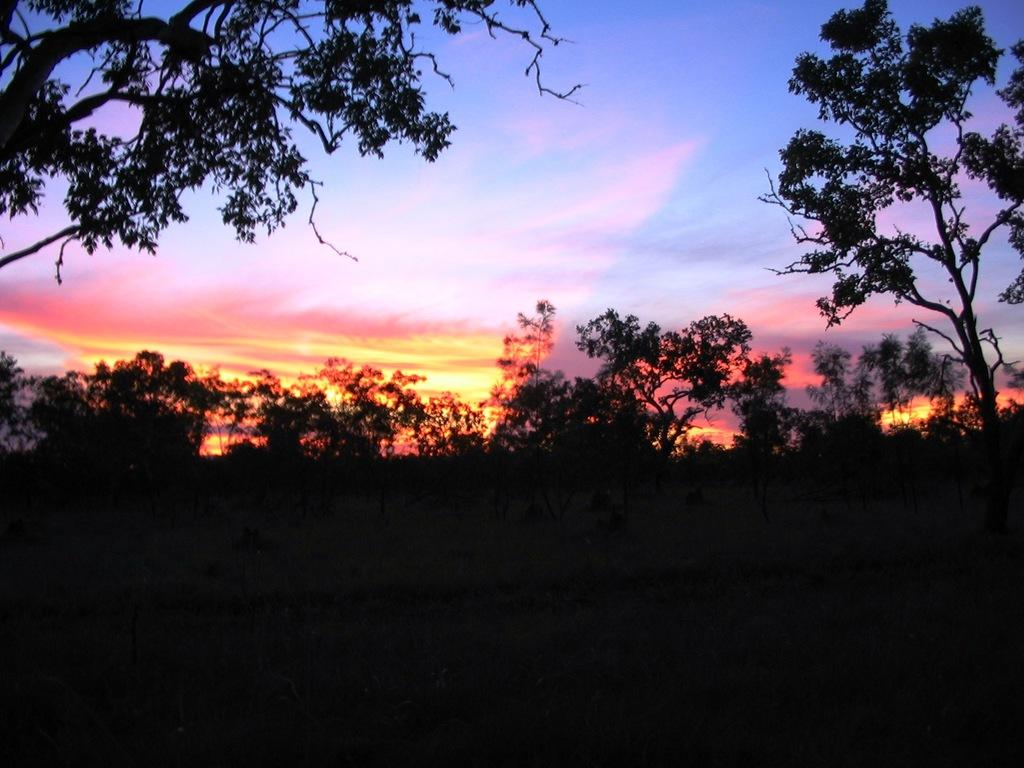What type of vegetation can be seen in the image? There are trees in the image. What can be seen in the sky in the image? There are clouds visible in the background of the image. What type of division is taking place between the trees in the image? There is no division taking place between the trees in the image; they are simply standing in the landscape. 